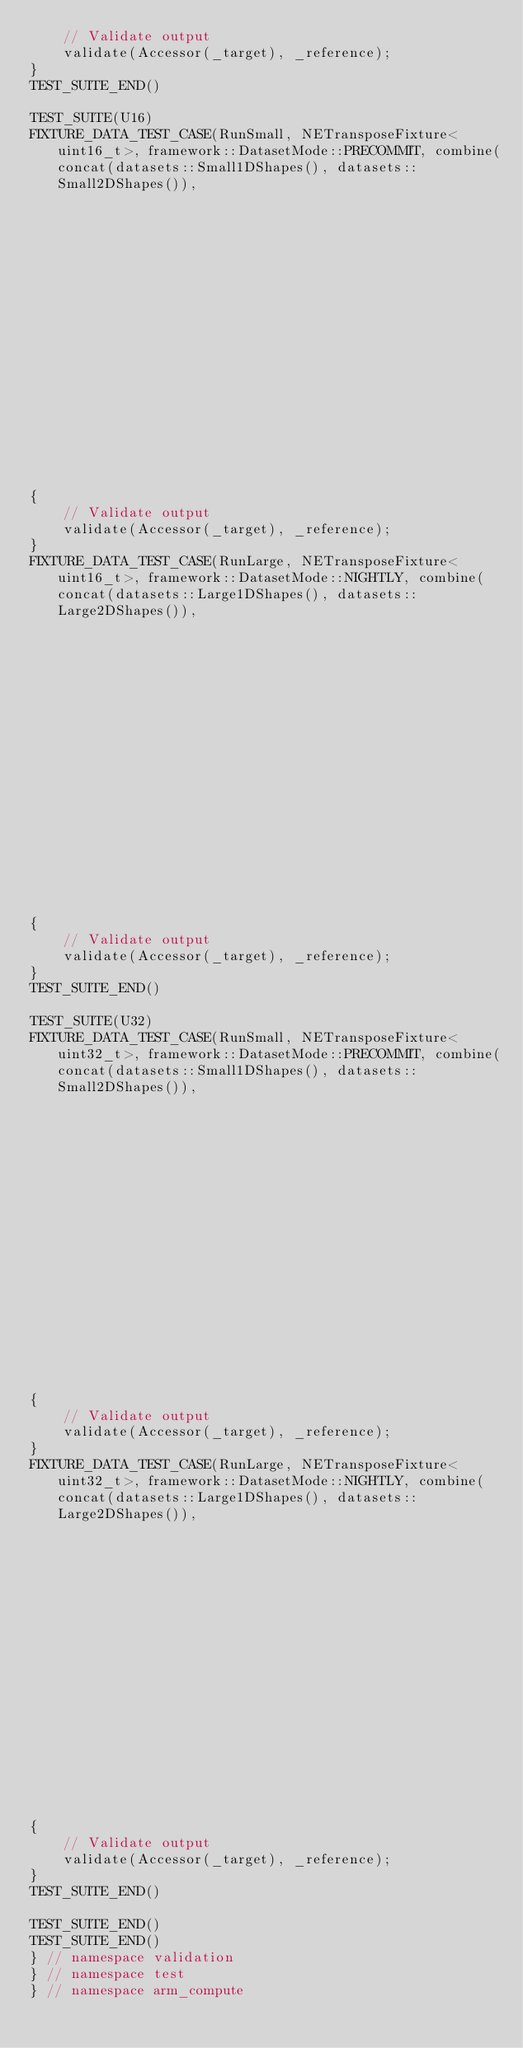<code> <loc_0><loc_0><loc_500><loc_500><_C++_>    // Validate output
    validate(Accessor(_target), _reference);
}
TEST_SUITE_END()

TEST_SUITE(U16)
FIXTURE_DATA_TEST_CASE(RunSmall, NETransposeFixture<uint16_t>, framework::DatasetMode::PRECOMMIT, combine(concat(datasets::Small1DShapes(), datasets::Small2DShapes()),
                                                                                                          framework::dataset::make("DataType", DataType::U16)))
{
    // Validate output
    validate(Accessor(_target), _reference);
}
FIXTURE_DATA_TEST_CASE(RunLarge, NETransposeFixture<uint16_t>, framework::DatasetMode::NIGHTLY, combine(concat(datasets::Large1DShapes(), datasets::Large2DShapes()),
                                                                                                        framework::dataset::make("DataType", DataType::U16)))
{
    // Validate output
    validate(Accessor(_target), _reference);
}
TEST_SUITE_END()

TEST_SUITE(U32)
FIXTURE_DATA_TEST_CASE(RunSmall, NETransposeFixture<uint32_t>, framework::DatasetMode::PRECOMMIT, combine(concat(datasets::Small1DShapes(), datasets::Small2DShapes()),
                                                                                                          framework::dataset::make("DataType", DataType::U32)))
{
    // Validate output
    validate(Accessor(_target), _reference);
}
FIXTURE_DATA_TEST_CASE(RunLarge, NETransposeFixture<uint32_t>, framework::DatasetMode::NIGHTLY, combine(concat(datasets::Large1DShapes(), datasets::Large2DShapes()),
                                                                                                        framework::dataset::make("DataType", DataType::U32)))
{
    // Validate output
    validate(Accessor(_target), _reference);
}
TEST_SUITE_END()

TEST_SUITE_END()
TEST_SUITE_END()
} // namespace validation
} // namespace test
} // namespace arm_compute
</code> 